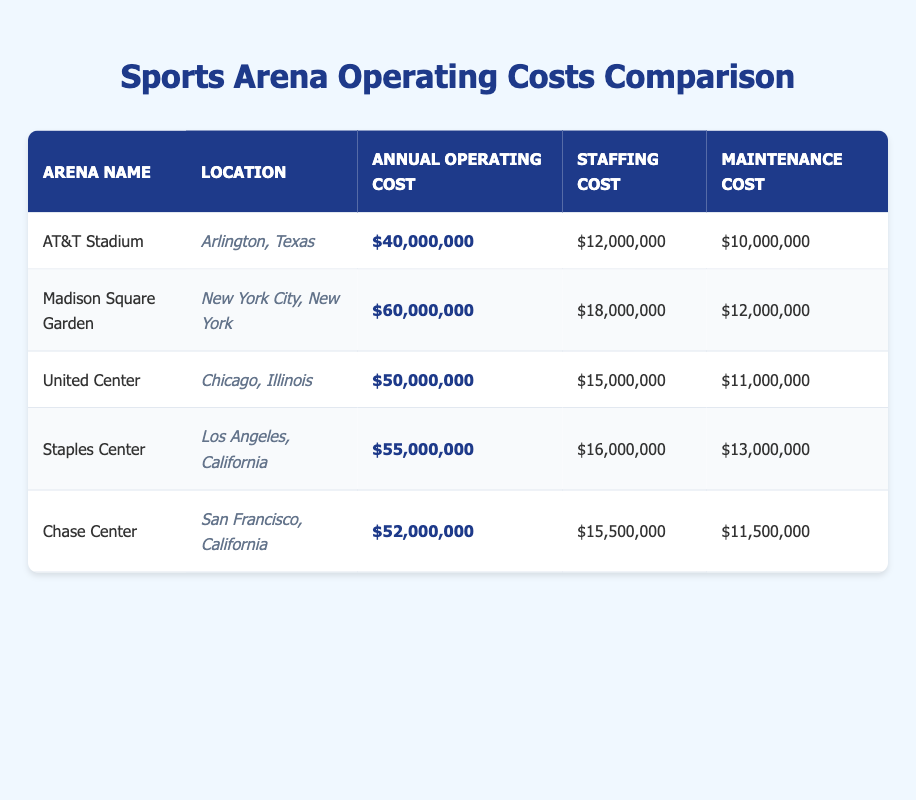What is the annual operating cost of Madison Square Garden? The table shows that Madison Square Garden has an annual operating cost listed as $60,000,000.
Answer: $60,000,000 Which arena has the highest staffing cost? By reviewing the staffing costs listed in the table, Madison Square Garden has the highest staffing cost at $18,000,000.
Answer: Madison Square Garden What is the total maintenance cost for AT&T Stadium and United Center combined? The maintenance cost for AT&T Stadium is $10,000,000 and for United Center is $11,000,000. Combining these amounts gives $10,000,000 + $11,000,000 = $21,000,000.
Answer: $21,000,000 Is the annual operating cost of the United Center greater than that of the Staples Center? The United Center has an operating cost of $50,000,000, while Staples Center has $55,000,000. Since $50,000,000 is less than $55,000,000, this statement is false.
Answer: No Which arena has the lowest total operating costs when considering staffing, maintenance, and utilities together? For AT&T Stadium, the sum of staffing, maintenance, and utilities is $12,000,000 + $10,000,000 + $8,000,000 = $30,000,000. For United Center, it's $15,000,000 + $11,000,000 + $13,000,000 = $39,000,000, and for Madison Square Garden, it's $18,000,000 + $12,000,000 + $15,000,000 = $45,000,000, and so forth. The lowest total comes from AT&T Stadium at $30,000,000.
Answer: AT&T Stadium What is the average annual operating cost of all arenas listed? The total annual operating costs are $40,000,000 + $60,000,000 + $50,000,000 + $55,000,000 + $52,000,000, which sums to $257,000,000. With 5 arenas, the average is $257,000,000 / 5 = $51,400,000.
Answer: $51,400,000 Which arena’s total operational cost is closer to the average annual operating cost? We calculated the average as $51,400,000. Comparing each arena's costs, United Center at $50,000,000 is the closest to the average value.
Answer: United Center Does Chase Center have a higher security cost than the average security cost of the arenas? The security costs are $5,000,000, $6,000,000, $7,000,000, $6,500,000, and $5,500,000 for the respective arenas. The average security cost is ($5,000,000 + $6,000,000 + $7,000,000 + $6,500,000 + $5,500,000) / 5 = $6,000,000. Since Chase Center has $5,500,000, which is less than the average, the statement is false.
Answer: No How much more does Madison Square Garden spend on utilities compared to AT&T Stadium? Madison Square Garden’s utilities cost is $15,000,000, while AT&T Stadium’s is $8,000,000. The difference is $15,000,000 - $8,000,000 = $7,000,000.
Answer: $7,000,000 What is the combined annual operating cost for Staples Center and Chase Center? Staples Center has an operating cost of $55,000,000 and Chase Center has $52,000,000. Thus the combined annual operating cost is $55,000,000 + $52,000,000 = $107,000,000.
Answer: $107,000,000 